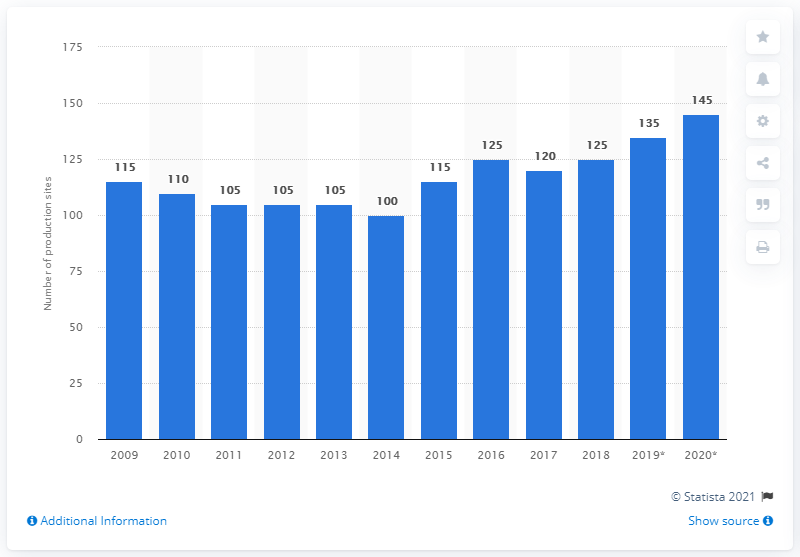Mention a couple of crucial points in this snapshot. There were 125 production locations in the Netherlands in 2014. In 2014, there were 100 ice cream production locations in the Netherlands. In the year 2020, there were 145 ice cream production locations in the Netherlands. 